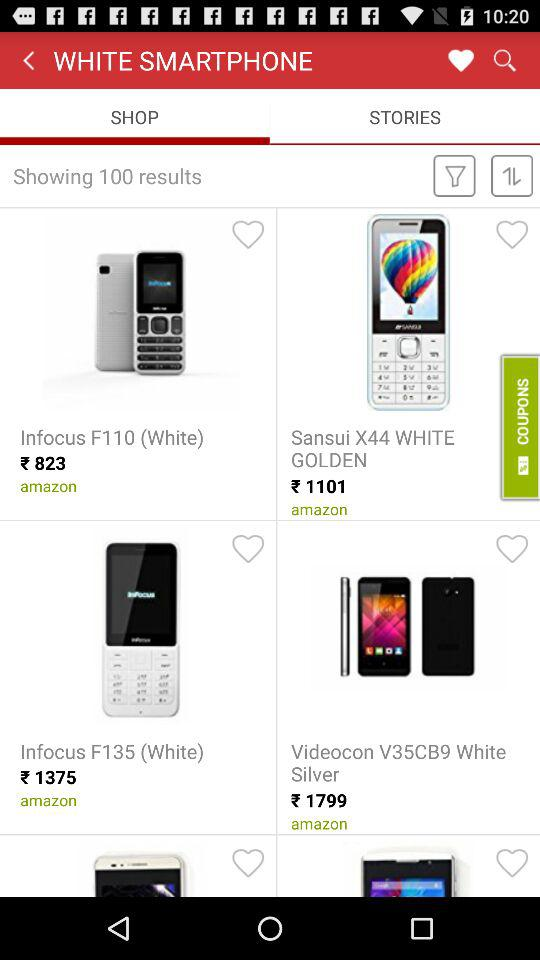What is the price of "Infocus F110 (White)"? The price of "Infocus F110 (White)" is ₹823. 